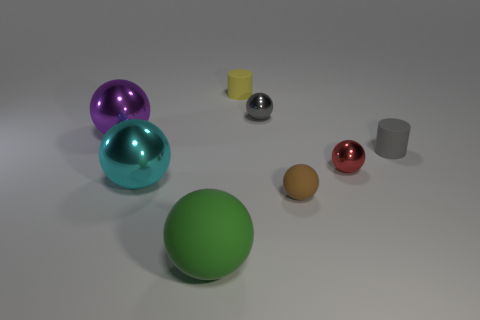The other big matte object that is the same shape as the brown thing is what color?
Offer a very short reply. Green. There is a green ball that is in front of the small rubber cylinder that is in front of the tiny rubber thing that is behind the purple metal ball; what is its size?
Your answer should be very brief. Large. There is a big thing in front of the rubber sphere to the right of the small yellow thing; what is it made of?
Your answer should be compact. Rubber. Are there any large green objects of the same shape as the big cyan object?
Offer a very short reply. Yes. What shape is the large cyan object?
Your answer should be very brief. Sphere. There is a tiny cylinder on the right side of the rubber object that is behind the small rubber cylinder that is in front of the yellow matte object; what is it made of?
Your answer should be compact. Rubber. Is the number of small brown rubber objects that are right of the brown rubber sphere greater than the number of yellow cylinders?
Your answer should be very brief. No. There is a gray cylinder that is the same size as the gray metal object; what material is it?
Provide a short and direct response. Rubber. Is there a gray rubber thing that has the same size as the cyan sphere?
Make the answer very short. No. What is the size of the rubber sphere that is left of the yellow rubber cylinder?
Offer a very short reply. Large. 